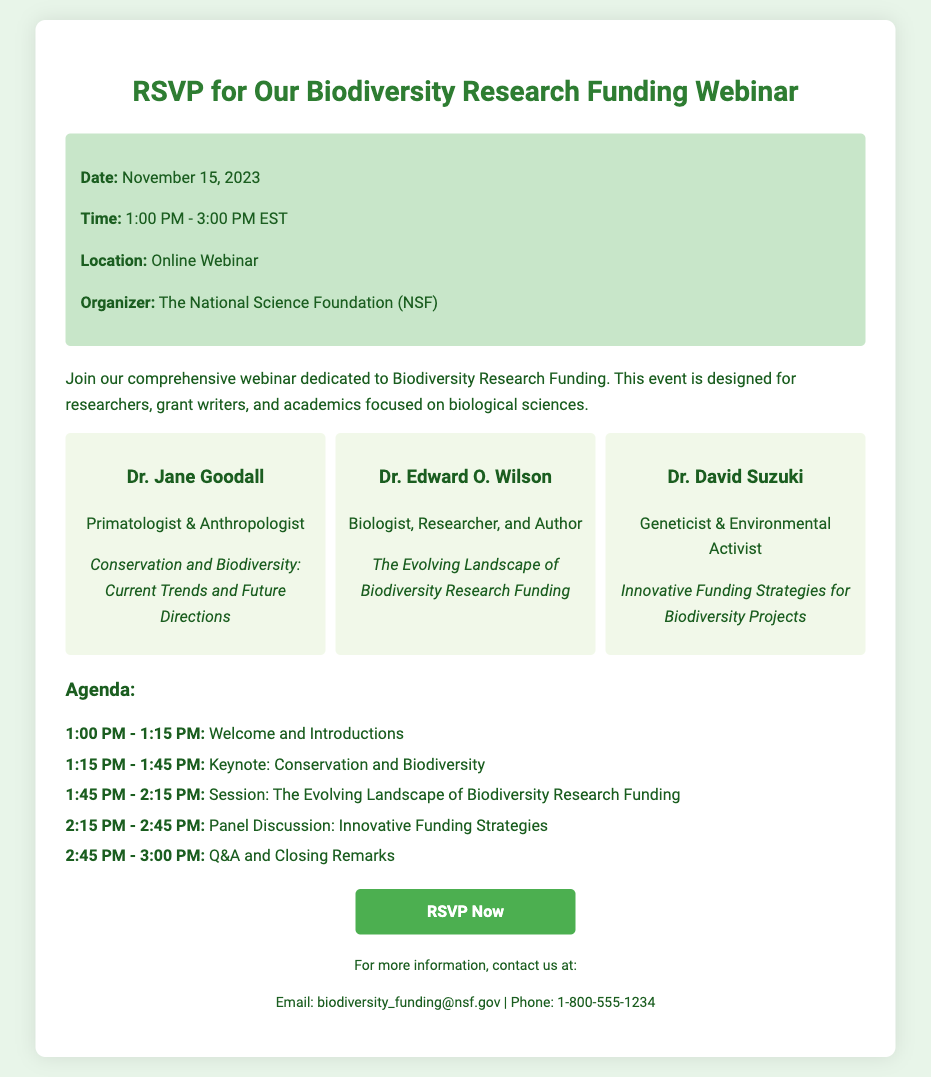What is the date of the webinar? The date of the webinar is explicitly mentioned in the document.
Answer: November 15, 2023 Who is the organizer of the webinar? The document specifies the organization responsible for the event.
Answer: The National Science Foundation (NSF) What time does the webinar start? The starting time is clearly indicated in the event details section.
Answer: 1:00 PM Name one speaker at the webinar. The document lists several speakers, making this information readily available.
Answer: Dr. Jane Goodall What topic will Dr. David Suzuki discuss? The speaker and their respective topics are outlined in the section dedicated to speakers.
Answer: Innovative Funding Strategies for Biodiversity Projects What is the duration of the opening welcome? The agenda provides the time allocated for each segment of the webinar.
Answer: 15 minutes How many speakers are featured in the webinar? The speaker section details the number of individuals participating in the event.
Answer: Three What is the format of the event? The document mentions the nature of the event, indicating it is an online session.
Answer: Online Webinar What is the email contact for more information? The contact information section contains specific details for inquiries.
Answer: biodiversity_funding@nsf.gov 